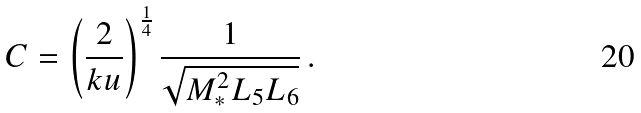Convert formula to latex. <formula><loc_0><loc_0><loc_500><loc_500>C = \left ( \frac { 2 } { k u } \right ) ^ { \frac { 1 } { 4 } } \frac { 1 } { \sqrt { M _ { * } ^ { 2 } L _ { 5 } L _ { 6 } } } \, .</formula> 